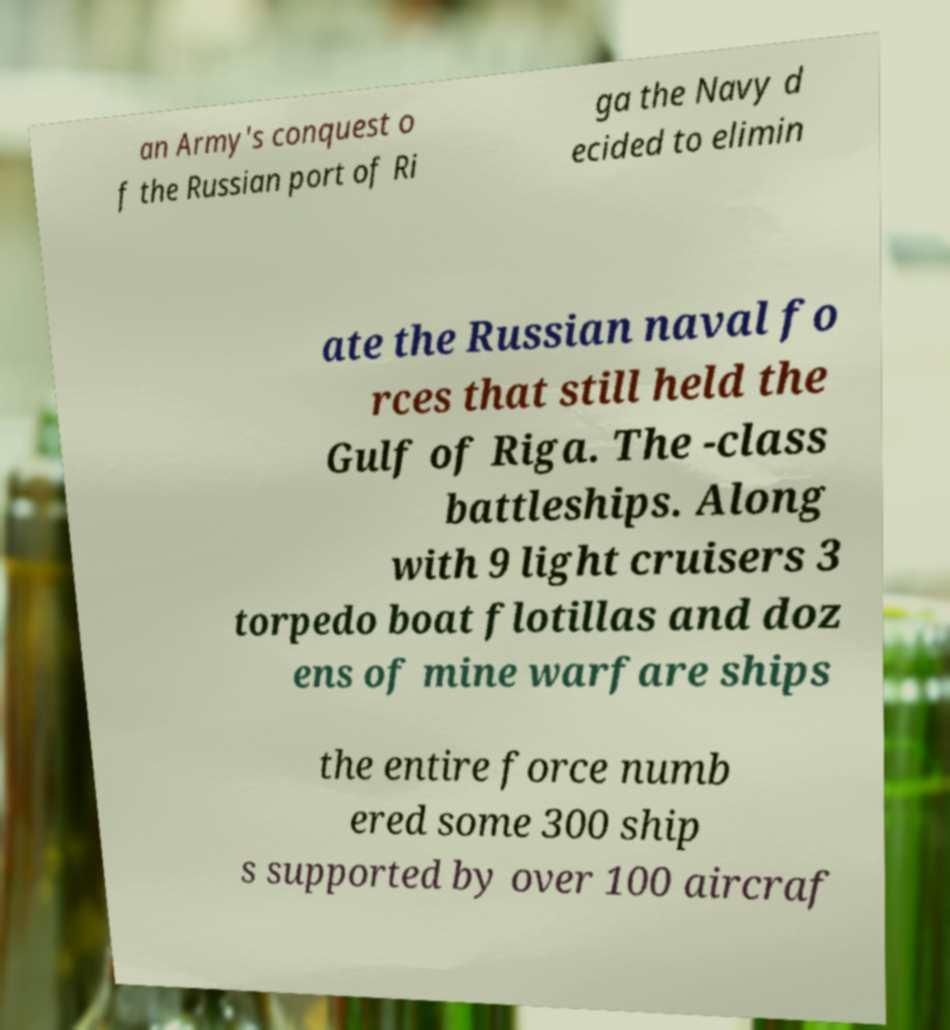Can you read and provide the text displayed in the image?This photo seems to have some interesting text. Can you extract and type it out for me? an Army's conquest o f the Russian port of Ri ga the Navy d ecided to elimin ate the Russian naval fo rces that still held the Gulf of Riga. The -class battleships. Along with 9 light cruisers 3 torpedo boat flotillas and doz ens of mine warfare ships the entire force numb ered some 300 ship s supported by over 100 aircraf 